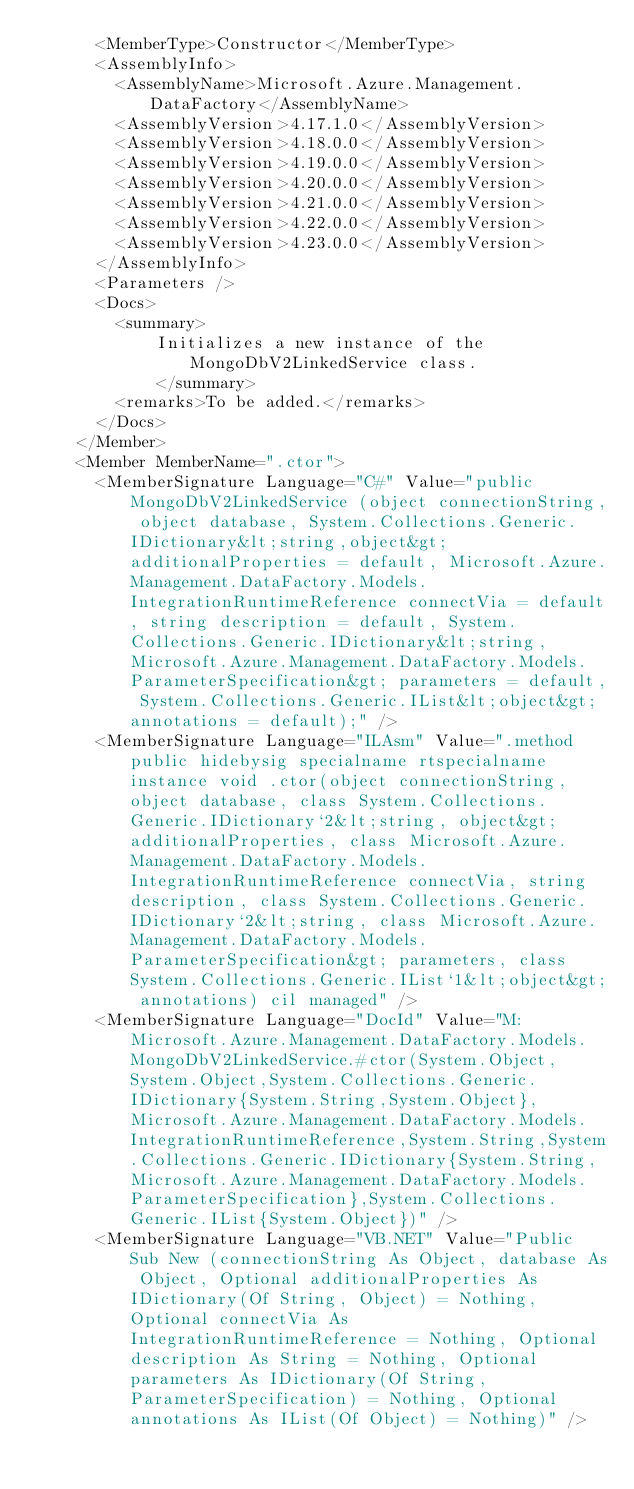Convert code to text. <code><loc_0><loc_0><loc_500><loc_500><_XML_>      <MemberType>Constructor</MemberType>
      <AssemblyInfo>
        <AssemblyName>Microsoft.Azure.Management.DataFactory</AssemblyName>
        <AssemblyVersion>4.17.1.0</AssemblyVersion>
        <AssemblyVersion>4.18.0.0</AssemblyVersion>
        <AssemblyVersion>4.19.0.0</AssemblyVersion>
        <AssemblyVersion>4.20.0.0</AssemblyVersion>
        <AssemblyVersion>4.21.0.0</AssemblyVersion>
        <AssemblyVersion>4.22.0.0</AssemblyVersion>
        <AssemblyVersion>4.23.0.0</AssemblyVersion>
      </AssemblyInfo>
      <Parameters />
      <Docs>
        <summary>
            Initializes a new instance of the MongoDbV2LinkedService class.
            </summary>
        <remarks>To be added.</remarks>
      </Docs>
    </Member>
    <Member MemberName=".ctor">
      <MemberSignature Language="C#" Value="public MongoDbV2LinkedService (object connectionString, object database, System.Collections.Generic.IDictionary&lt;string,object&gt; additionalProperties = default, Microsoft.Azure.Management.DataFactory.Models.IntegrationRuntimeReference connectVia = default, string description = default, System.Collections.Generic.IDictionary&lt;string,Microsoft.Azure.Management.DataFactory.Models.ParameterSpecification&gt; parameters = default, System.Collections.Generic.IList&lt;object&gt; annotations = default);" />
      <MemberSignature Language="ILAsm" Value=".method public hidebysig specialname rtspecialname instance void .ctor(object connectionString, object database, class System.Collections.Generic.IDictionary`2&lt;string, object&gt; additionalProperties, class Microsoft.Azure.Management.DataFactory.Models.IntegrationRuntimeReference connectVia, string description, class System.Collections.Generic.IDictionary`2&lt;string, class Microsoft.Azure.Management.DataFactory.Models.ParameterSpecification&gt; parameters, class System.Collections.Generic.IList`1&lt;object&gt; annotations) cil managed" />
      <MemberSignature Language="DocId" Value="M:Microsoft.Azure.Management.DataFactory.Models.MongoDbV2LinkedService.#ctor(System.Object,System.Object,System.Collections.Generic.IDictionary{System.String,System.Object},Microsoft.Azure.Management.DataFactory.Models.IntegrationRuntimeReference,System.String,System.Collections.Generic.IDictionary{System.String,Microsoft.Azure.Management.DataFactory.Models.ParameterSpecification},System.Collections.Generic.IList{System.Object})" />
      <MemberSignature Language="VB.NET" Value="Public Sub New (connectionString As Object, database As Object, Optional additionalProperties As IDictionary(Of String, Object) = Nothing, Optional connectVia As IntegrationRuntimeReference = Nothing, Optional description As String = Nothing, Optional parameters As IDictionary(Of String, ParameterSpecification) = Nothing, Optional annotations As IList(Of Object) = Nothing)" /></code> 